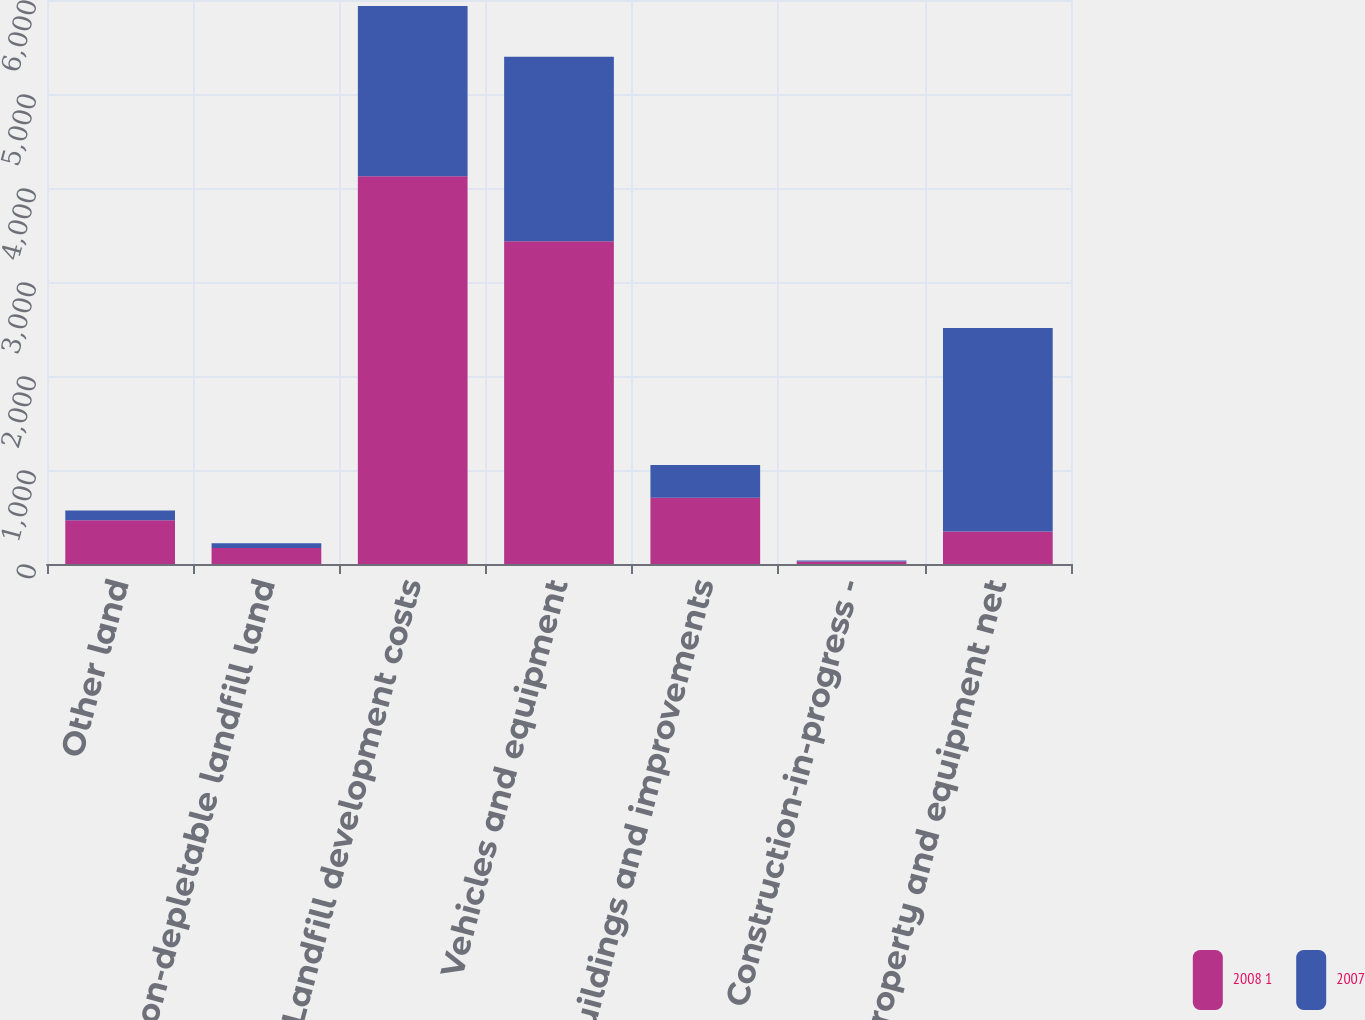<chart> <loc_0><loc_0><loc_500><loc_500><stacked_bar_chart><ecel><fcel>Other land<fcel>Non-depletable landfill land<fcel>Landfill development costs<fcel>Vehicles and equipment<fcel>Buildings and improvements<fcel>Construction-in-progress -<fcel>Property and equipment net<nl><fcel>2008 1<fcel>464.4<fcel>169.3<fcel>4126.3<fcel>3432.3<fcel>706<fcel>26.3<fcel>346.7<nl><fcel>2007<fcel>105.7<fcel>52.7<fcel>1809.1<fcel>1965.1<fcel>346.7<fcel>11.8<fcel>2164.3<nl></chart> 